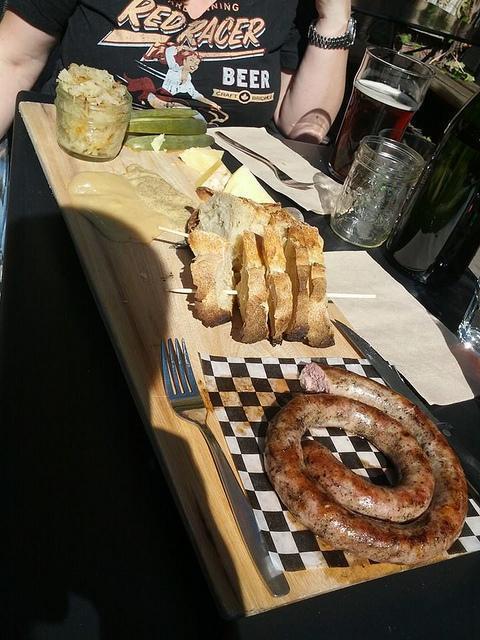How many cups are in the picture?
Give a very brief answer. 3. How many orange papers are on the toilet?
Give a very brief answer. 0. 